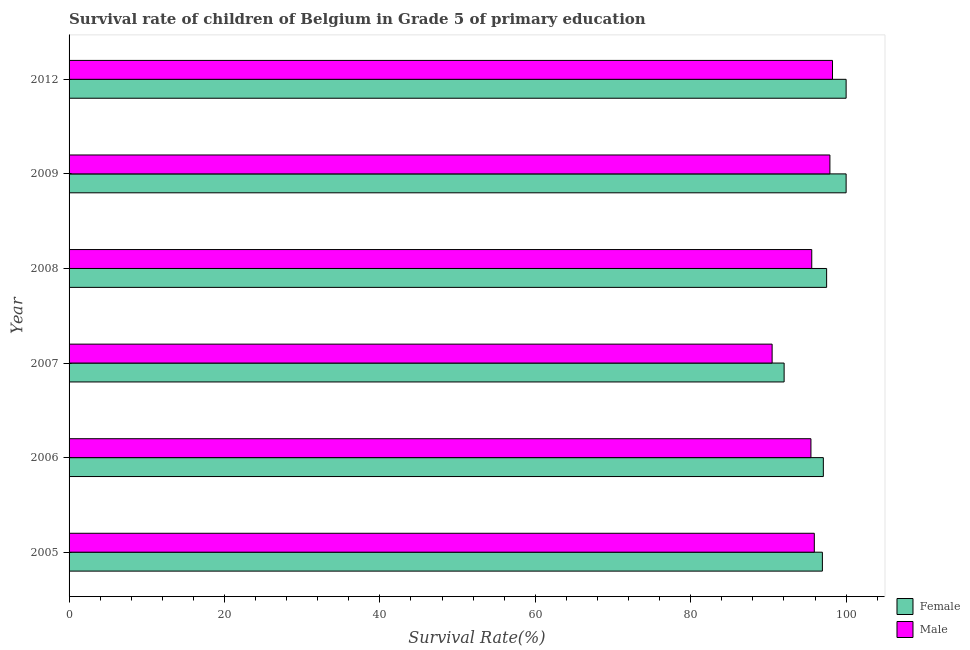Are the number of bars per tick equal to the number of legend labels?
Keep it short and to the point. Yes. How many bars are there on the 3rd tick from the top?
Offer a terse response. 2. What is the label of the 1st group of bars from the top?
Keep it short and to the point. 2012. In how many cases, is the number of bars for a given year not equal to the number of legend labels?
Your response must be concise. 0. What is the survival rate of male students in primary education in 2012?
Provide a succinct answer. 98.25. Across all years, what is the maximum survival rate of male students in primary education?
Your answer should be compact. 98.25. Across all years, what is the minimum survival rate of female students in primary education?
Your answer should be very brief. 92.02. In which year was the survival rate of female students in primary education minimum?
Your answer should be very brief. 2007. What is the total survival rate of female students in primary education in the graph?
Your answer should be compact. 583.53. What is the difference between the survival rate of male students in primary education in 2005 and that in 2007?
Make the answer very short. 5.43. What is the difference between the survival rate of male students in primary education in 2006 and the survival rate of female students in primary education in 2005?
Provide a short and direct response. -1.47. What is the average survival rate of female students in primary education per year?
Your response must be concise. 97.25. In the year 2007, what is the difference between the survival rate of female students in primary education and survival rate of male students in primary education?
Keep it short and to the point. 1.54. In how many years, is the survival rate of female students in primary education greater than 80 %?
Offer a very short reply. 6. Is the difference between the survival rate of female students in primary education in 2006 and 2007 greater than the difference between the survival rate of male students in primary education in 2006 and 2007?
Keep it short and to the point. Yes. What is the difference between the highest and the second highest survival rate of male students in primary education?
Make the answer very short. 0.34. What is the difference between the highest and the lowest survival rate of male students in primary education?
Your response must be concise. 7.77. What does the 2nd bar from the bottom in 2008 represents?
Provide a short and direct response. Male. How many bars are there?
Provide a succinct answer. 12. What is the difference between two consecutive major ticks on the X-axis?
Keep it short and to the point. 20. Does the graph contain any zero values?
Offer a terse response. No. Does the graph contain grids?
Give a very brief answer. No. How many legend labels are there?
Provide a short and direct response. 2. How are the legend labels stacked?
Keep it short and to the point. Vertical. What is the title of the graph?
Offer a very short reply. Survival rate of children of Belgium in Grade 5 of primary education. Does "Enforce a contract" appear as one of the legend labels in the graph?
Offer a very short reply. No. What is the label or title of the X-axis?
Offer a terse response. Survival Rate(%). What is the Survival Rate(%) of Female in 2005?
Make the answer very short. 96.95. What is the Survival Rate(%) in Male in 2005?
Provide a succinct answer. 95.91. What is the Survival Rate(%) in Female in 2006?
Make the answer very short. 97.07. What is the Survival Rate(%) in Male in 2006?
Your response must be concise. 95.47. What is the Survival Rate(%) in Female in 2007?
Offer a very short reply. 92.02. What is the Survival Rate(%) of Male in 2007?
Provide a short and direct response. 90.48. What is the Survival Rate(%) in Female in 2008?
Offer a very short reply. 97.49. What is the Survival Rate(%) of Male in 2008?
Provide a short and direct response. 95.58. What is the Survival Rate(%) of Female in 2009?
Keep it short and to the point. 100. What is the Survival Rate(%) of Male in 2009?
Offer a terse response. 97.91. What is the Survival Rate(%) of Male in 2012?
Offer a very short reply. 98.25. Across all years, what is the maximum Survival Rate(%) of Male?
Give a very brief answer. 98.25. Across all years, what is the minimum Survival Rate(%) in Female?
Offer a terse response. 92.02. Across all years, what is the minimum Survival Rate(%) of Male?
Give a very brief answer. 90.48. What is the total Survival Rate(%) in Female in the graph?
Provide a succinct answer. 583.53. What is the total Survival Rate(%) of Male in the graph?
Make the answer very short. 573.59. What is the difference between the Survival Rate(%) in Female in 2005 and that in 2006?
Ensure brevity in your answer.  -0.12. What is the difference between the Survival Rate(%) in Male in 2005 and that in 2006?
Make the answer very short. 0.43. What is the difference between the Survival Rate(%) in Female in 2005 and that in 2007?
Provide a short and direct response. 4.92. What is the difference between the Survival Rate(%) in Male in 2005 and that in 2007?
Make the answer very short. 5.43. What is the difference between the Survival Rate(%) of Female in 2005 and that in 2008?
Your answer should be very brief. -0.55. What is the difference between the Survival Rate(%) in Male in 2005 and that in 2008?
Make the answer very short. 0.33. What is the difference between the Survival Rate(%) of Female in 2005 and that in 2009?
Make the answer very short. -3.05. What is the difference between the Survival Rate(%) of Male in 2005 and that in 2009?
Give a very brief answer. -2.01. What is the difference between the Survival Rate(%) in Female in 2005 and that in 2012?
Your answer should be compact. -3.05. What is the difference between the Survival Rate(%) of Male in 2005 and that in 2012?
Make the answer very short. -2.34. What is the difference between the Survival Rate(%) in Female in 2006 and that in 2007?
Make the answer very short. 5.05. What is the difference between the Survival Rate(%) of Male in 2006 and that in 2007?
Provide a short and direct response. 5. What is the difference between the Survival Rate(%) in Female in 2006 and that in 2008?
Provide a short and direct response. -0.42. What is the difference between the Survival Rate(%) in Male in 2006 and that in 2008?
Your response must be concise. -0.1. What is the difference between the Survival Rate(%) in Female in 2006 and that in 2009?
Provide a succinct answer. -2.93. What is the difference between the Survival Rate(%) in Male in 2006 and that in 2009?
Ensure brevity in your answer.  -2.44. What is the difference between the Survival Rate(%) in Female in 2006 and that in 2012?
Provide a short and direct response. -2.93. What is the difference between the Survival Rate(%) in Male in 2006 and that in 2012?
Keep it short and to the point. -2.78. What is the difference between the Survival Rate(%) in Female in 2007 and that in 2008?
Offer a very short reply. -5.47. What is the difference between the Survival Rate(%) in Male in 2007 and that in 2008?
Your answer should be compact. -5.1. What is the difference between the Survival Rate(%) of Female in 2007 and that in 2009?
Keep it short and to the point. -7.98. What is the difference between the Survival Rate(%) in Male in 2007 and that in 2009?
Offer a very short reply. -7.44. What is the difference between the Survival Rate(%) of Female in 2007 and that in 2012?
Your answer should be very brief. -7.98. What is the difference between the Survival Rate(%) in Male in 2007 and that in 2012?
Give a very brief answer. -7.77. What is the difference between the Survival Rate(%) in Female in 2008 and that in 2009?
Make the answer very short. -2.51. What is the difference between the Survival Rate(%) of Male in 2008 and that in 2009?
Your response must be concise. -2.34. What is the difference between the Survival Rate(%) in Female in 2008 and that in 2012?
Keep it short and to the point. -2.51. What is the difference between the Survival Rate(%) in Male in 2008 and that in 2012?
Provide a succinct answer. -2.67. What is the difference between the Survival Rate(%) in Male in 2009 and that in 2012?
Give a very brief answer. -0.34. What is the difference between the Survival Rate(%) of Female in 2005 and the Survival Rate(%) of Male in 2006?
Offer a terse response. 1.47. What is the difference between the Survival Rate(%) in Female in 2005 and the Survival Rate(%) in Male in 2007?
Your answer should be very brief. 6.47. What is the difference between the Survival Rate(%) in Female in 2005 and the Survival Rate(%) in Male in 2008?
Make the answer very short. 1.37. What is the difference between the Survival Rate(%) of Female in 2005 and the Survival Rate(%) of Male in 2009?
Your answer should be compact. -0.97. What is the difference between the Survival Rate(%) in Female in 2005 and the Survival Rate(%) in Male in 2012?
Give a very brief answer. -1.3. What is the difference between the Survival Rate(%) in Female in 2006 and the Survival Rate(%) in Male in 2007?
Provide a short and direct response. 6.59. What is the difference between the Survival Rate(%) of Female in 2006 and the Survival Rate(%) of Male in 2008?
Offer a terse response. 1.49. What is the difference between the Survival Rate(%) in Female in 2006 and the Survival Rate(%) in Male in 2009?
Offer a very short reply. -0.85. What is the difference between the Survival Rate(%) in Female in 2006 and the Survival Rate(%) in Male in 2012?
Provide a short and direct response. -1.18. What is the difference between the Survival Rate(%) of Female in 2007 and the Survival Rate(%) of Male in 2008?
Offer a very short reply. -3.55. What is the difference between the Survival Rate(%) in Female in 2007 and the Survival Rate(%) in Male in 2009?
Provide a short and direct response. -5.89. What is the difference between the Survival Rate(%) in Female in 2007 and the Survival Rate(%) in Male in 2012?
Keep it short and to the point. -6.23. What is the difference between the Survival Rate(%) of Female in 2008 and the Survival Rate(%) of Male in 2009?
Keep it short and to the point. -0.42. What is the difference between the Survival Rate(%) in Female in 2008 and the Survival Rate(%) in Male in 2012?
Offer a terse response. -0.76. What is the difference between the Survival Rate(%) in Female in 2009 and the Survival Rate(%) in Male in 2012?
Offer a terse response. 1.75. What is the average Survival Rate(%) in Female per year?
Offer a terse response. 97.25. What is the average Survival Rate(%) in Male per year?
Provide a short and direct response. 95.6. In the year 2005, what is the difference between the Survival Rate(%) in Female and Survival Rate(%) in Male?
Your answer should be compact. 1.04. In the year 2006, what is the difference between the Survival Rate(%) of Female and Survival Rate(%) of Male?
Ensure brevity in your answer.  1.6. In the year 2007, what is the difference between the Survival Rate(%) of Female and Survival Rate(%) of Male?
Provide a succinct answer. 1.55. In the year 2008, what is the difference between the Survival Rate(%) in Female and Survival Rate(%) in Male?
Make the answer very short. 1.92. In the year 2009, what is the difference between the Survival Rate(%) of Female and Survival Rate(%) of Male?
Make the answer very short. 2.09. In the year 2012, what is the difference between the Survival Rate(%) of Female and Survival Rate(%) of Male?
Give a very brief answer. 1.75. What is the ratio of the Survival Rate(%) of Female in 2005 to that in 2006?
Keep it short and to the point. 1. What is the ratio of the Survival Rate(%) of Female in 2005 to that in 2007?
Your answer should be very brief. 1.05. What is the ratio of the Survival Rate(%) of Male in 2005 to that in 2007?
Provide a succinct answer. 1.06. What is the ratio of the Survival Rate(%) of Female in 2005 to that in 2009?
Provide a short and direct response. 0.97. What is the ratio of the Survival Rate(%) of Male in 2005 to that in 2009?
Make the answer very short. 0.98. What is the ratio of the Survival Rate(%) in Female in 2005 to that in 2012?
Your answer should be very brief. 0.97. What is the ratio of the Survival Rate(%) in Male in 2005 to that in 2012?
Offer a terse response. 0.98. What is the ratio of the Survival Rate(%) in Female in 2006 to that in 2007?
Keep it short and to the point. 1.05. What is the ratio of the Survival Rate(%) of Male in 2006 to that in 2007?
Your answer should be very brief. 1.06. What is the ratio of the Survival Rate(%) of Female in 2006 to that in 2009?
Your answer should be compact. 0.97. What is the ratio of the Survival Rate(%) in Male in 2006 to that in 2009?
Your answer should be compact. 0.98. What is the ratio of the Survival Rate(%) of Female in 2006 to that in 2012?
Your response must be concise. 0.97. What is the ratio of the Survival Rate(%) in Male in 2006 to that in 2012?
Your answer should be very brief. 0.97. What is the ratio of the Survival Rate(%) of Female in 2007 to that in 2008?
Your response must be concise. 0.94. What is the ratio of the Survival Rate(%) in Male in 2007 to that in 2008?
Your answer should be compact. 0.95. What is the ratio of the Survival Rate(%) in Female in 2007 to that in 2009?
Provide a short and direct response. 0.92. What is the ratio of the Survival Rate(%) of Male in 2007 to that in 2009?
Ensure brevity in your answer.  0.92. What is the ratio of the Survival Rate(%) of Female in 2007 to that in 2012?
Ensure brevity in your answer.  0.92. What is the ratio of the Survival Rate(%) in Male in 2007 to that in 2012?
Make the answer very short. 0.92. What is the ratio of the Survival Rate(%) in Female in 2008 to that in 2009?
Keep it short and to the point. 0.97. What is the ratio of the Survival Rate(%) of Male in 2008 to that in 2009?
Your answer should be very brief. 0.98. What is the ratio of the Survival Rate(%) in Female in 2008 to that in 2012?
Offer a very short reply. 0.97. What is the ratio of the Survival Rate(%) of Male in 2008 to that in 2012?
Offer a terse response. 0.97. What is the ratio of the Survival Rate(%) in Female in 2009 to that in 2012?
Your answer should be very brief. 1. What is the difference between the highest and the second highest Survival Rate(%) in Male?
Keep it short and to the point. 0.34. What is the difference between the highest and the lowest Survival Rate(%) of Female?
Offer a very short reply. 7.98. What is the difference between the highest and the lowest Survival Rate(%) of Male?
Provide a short and direct response. 7.77. 